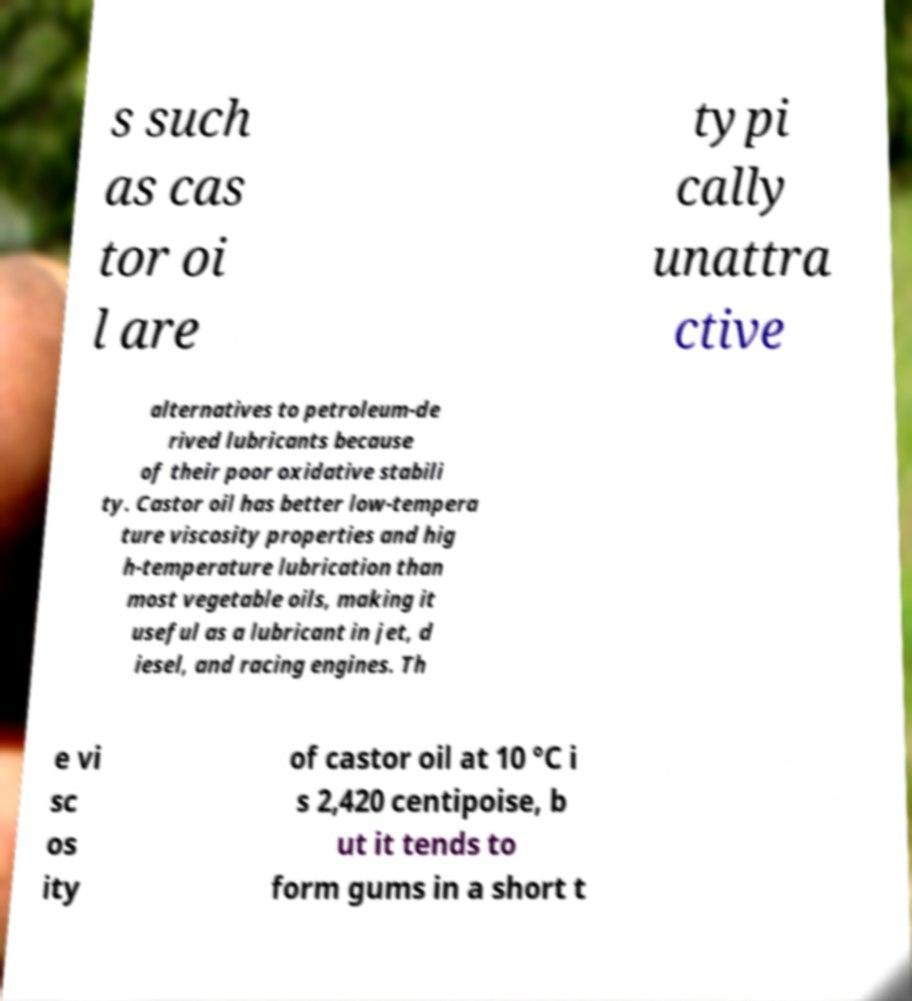What messages or text are displayed in this image? I need them in a readable, typed format. s such as cas tor oi l are typi cally unattra ctive alternatives to petroleum-de rived lubricants because of their poor oxidative stabili ty. Castor oil has better low-tempera ture viscosity properties and hig h-temperature lubrication than most vegetable oils, making it useful as a lubricant in jet, d iesel, and racing engines. Th e vi sc os ity of castor oil at 10 °C i s 2,420 centipoise, b ut it tends to form gums in a short t 